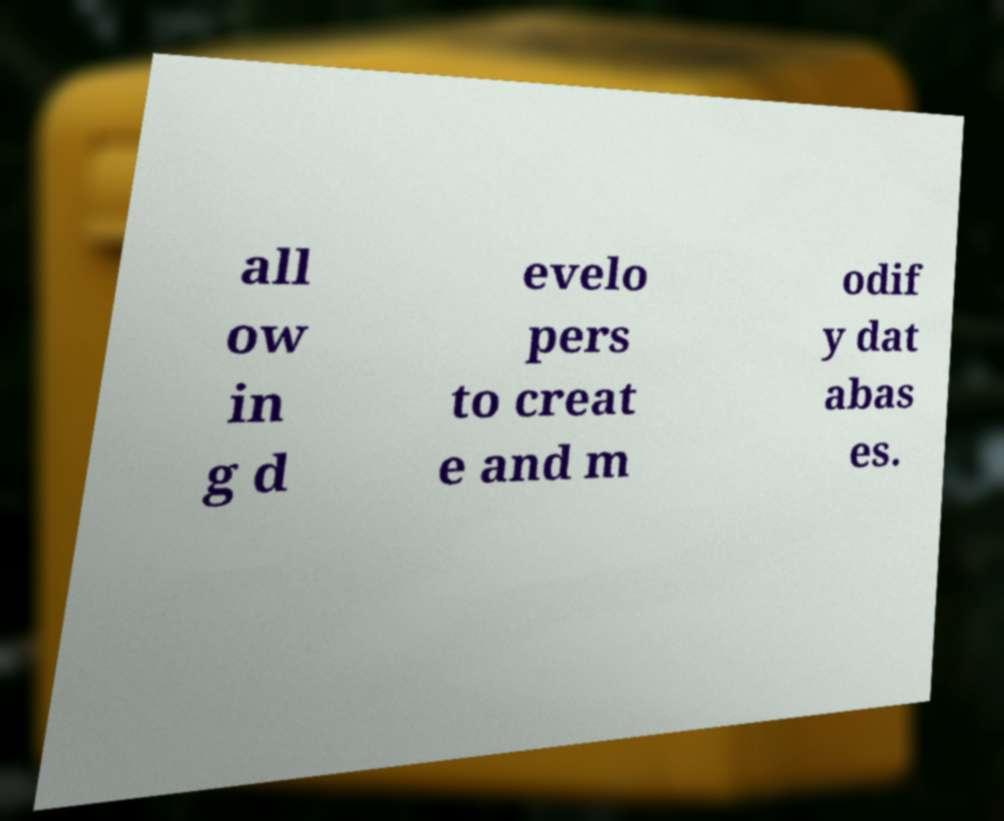There's text embedded in this image that I need extracted. Can you transcribe it verbatim? all ow in g d evelo pers to creat e and m odif y dat abas es. 